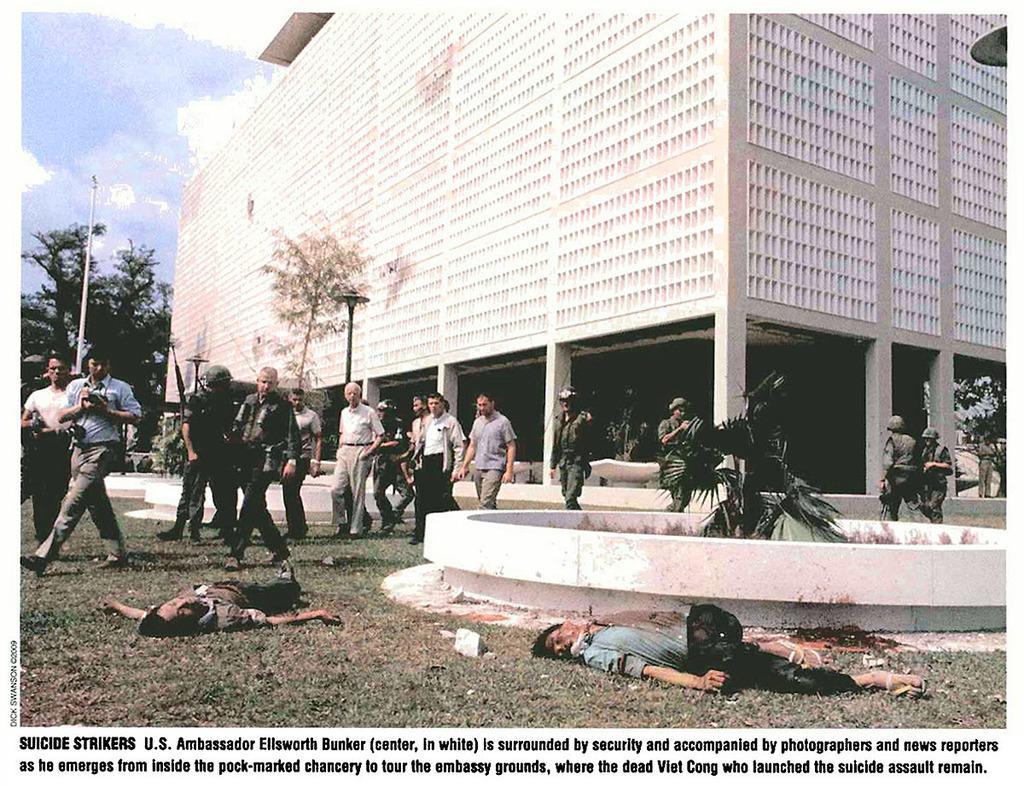In one or two sentences, can you explain what this image depicts? In this image we can see some people and among them two persons lying on the ground and we can see some plants and trees. There is a building in the background and we can see some light poles and there is some text at the bottom of the image and at the top we can see the sky. 